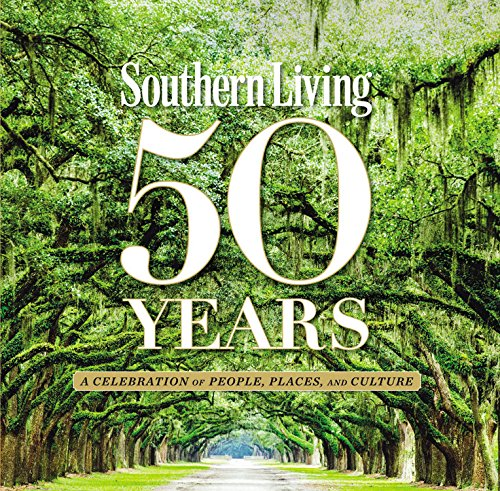Who is the author of this book? The book 'Southern Living 50 Years: A Celebration of People, Places, and Culture' is authored collaboratively by The Editors of Southern Living Magazine, showcasing a collective editorial effort rather than a single author. 